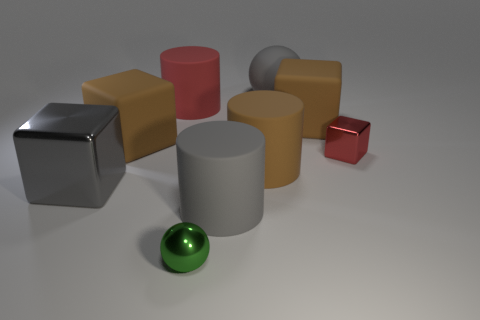What number of metal objects are either red cylinders or cylinders?
Give a very brief answer. 0. There is a gray metallic cube; how many small metal spheres are behind it?
Offer a terse response. 0. Are there any brown cubes that have the same size as the brown rubber cylinder?
Make the answer very short. Yes. Are there any other matte spheres that have the same color as the big matte ball?
Provide a short and direct response. No. How many metallic things have the same color as the small ball?
Offer a very short reply. 0. Does the tiny cube have the same color as the big cylinder left of the tiny green metal thing?
Provide a succinct answer. Yes. How many things are big gray matte balls or rubber things that are on the right side of the large red thing?
Ensure brevity in your answer.  4. There is a gray matte object behind the shiny cube right of the gray metallic block; what is its size?
Keep it short and to the point. Large. Are there an equal number of large gray metallic blocks on the left side of the big gray matte cylinder and big gray matte things that are behind the big gray metal object?
Offer a terse response. Yes. There is a gray matte object to the right of the big gray rubber cylinder; are there any small metal balls to the left of it?
Offer a terse response. Yes. 